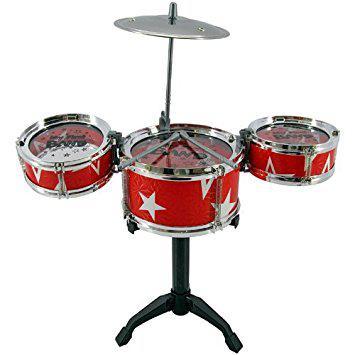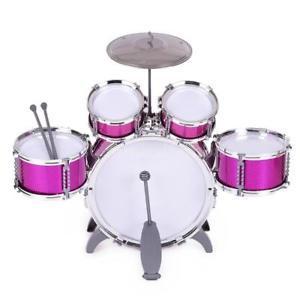The first image is the image on the left, the second image is the image on the right. Analyze the images presented: Is the assertion "One drum set consists of three drums in a row and a high hat above them." valid? Answer yes or no. Yes. The first image is the image on the left, the second image is the image on the right. Analyze the images presented: Is the assertion "Eight or more drums are visible." valid? Answer yes or no. Yes. 